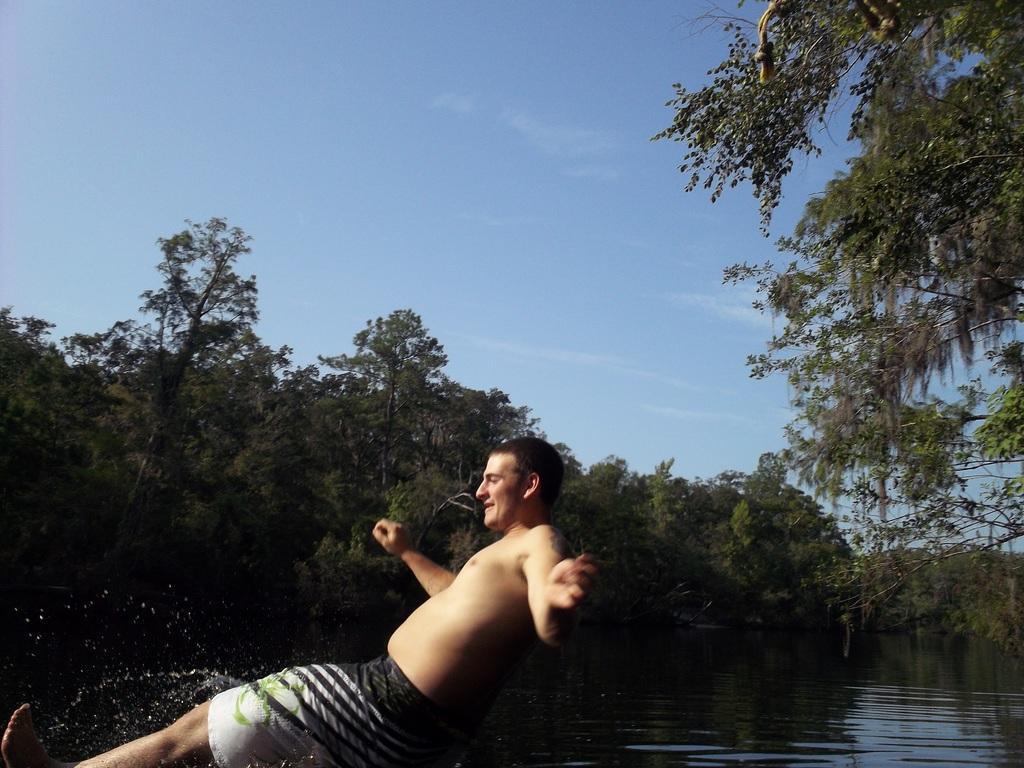Please provide a concise description of this image. In this picture there is man wearing shorts is jumping into the river water. Behind there are some trees and on the right corner we can see the tree. 